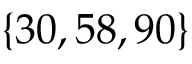Convert formula to latex. <formula><loc_0><loc_0><loc_500><loc_500>\{ 3 0 , 5 8 , 9 0 \}</formula> 